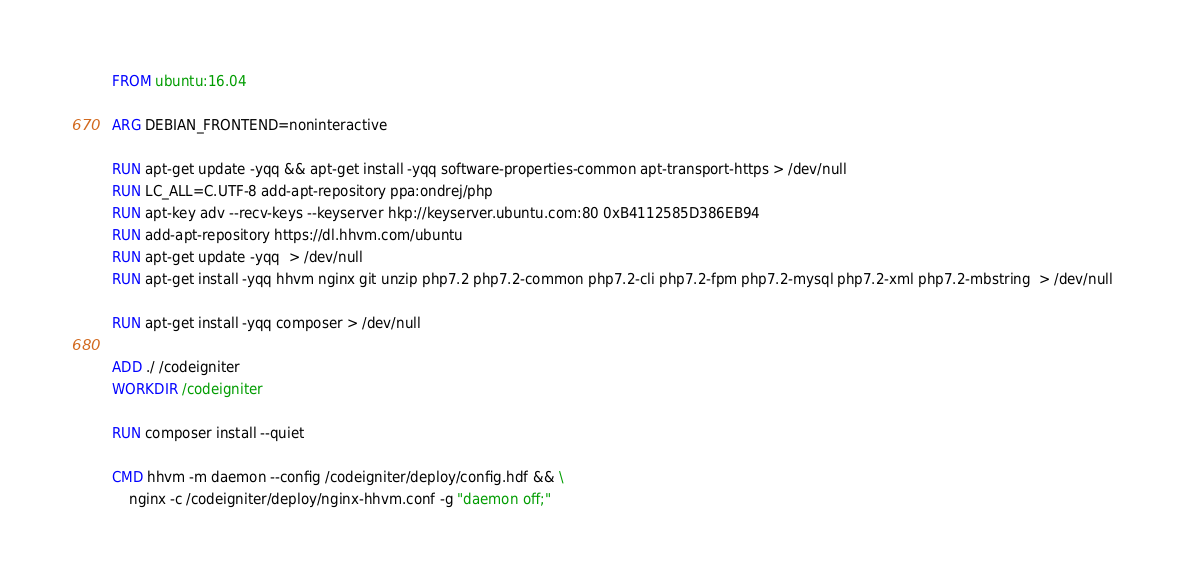<code> <loc_0><loc_0><loc_500><loc_500><_Dockerfile_>FROM ubuntu:16.04

ARG DEBIAN_FRONTEND=noninteractive

RUN apt-get update -yqq && apt-get install -yqq software-properties-common apt-transport-https > /dev/null
RUN LC_ALL=C.UTF-8 add-apt-repository ppa:ondrej/php
RUN apt-key adv --recv-keys --keyserver hkp://keyserver.ubuntu.com:80 0xB4112585D386EB94
RUN add-apt-repository https://dl.hhvm.com/ubuntu
RUN apt-get update -yqq  > /dev/null
RUN apt-get install -yqq hhvm nginx git unzip php7.2 php7.2-common php7.2-cli php7.2-fpm php7.2-mysql php7.2-xml php7.2-mbstring  > /dev/null

RUN apt-get install -yqq composer > /dev/null

ADD ./ /codeigniter
WORKDIR /codeigniter

RUN composer install --quiet

CMD hhvm -m daemon --config /codeigniter/deploy/config.hdf && \
    nginx -c /codeigniter/deploy/nginx-hhvm.conf -g "daemon off;"
</code> 